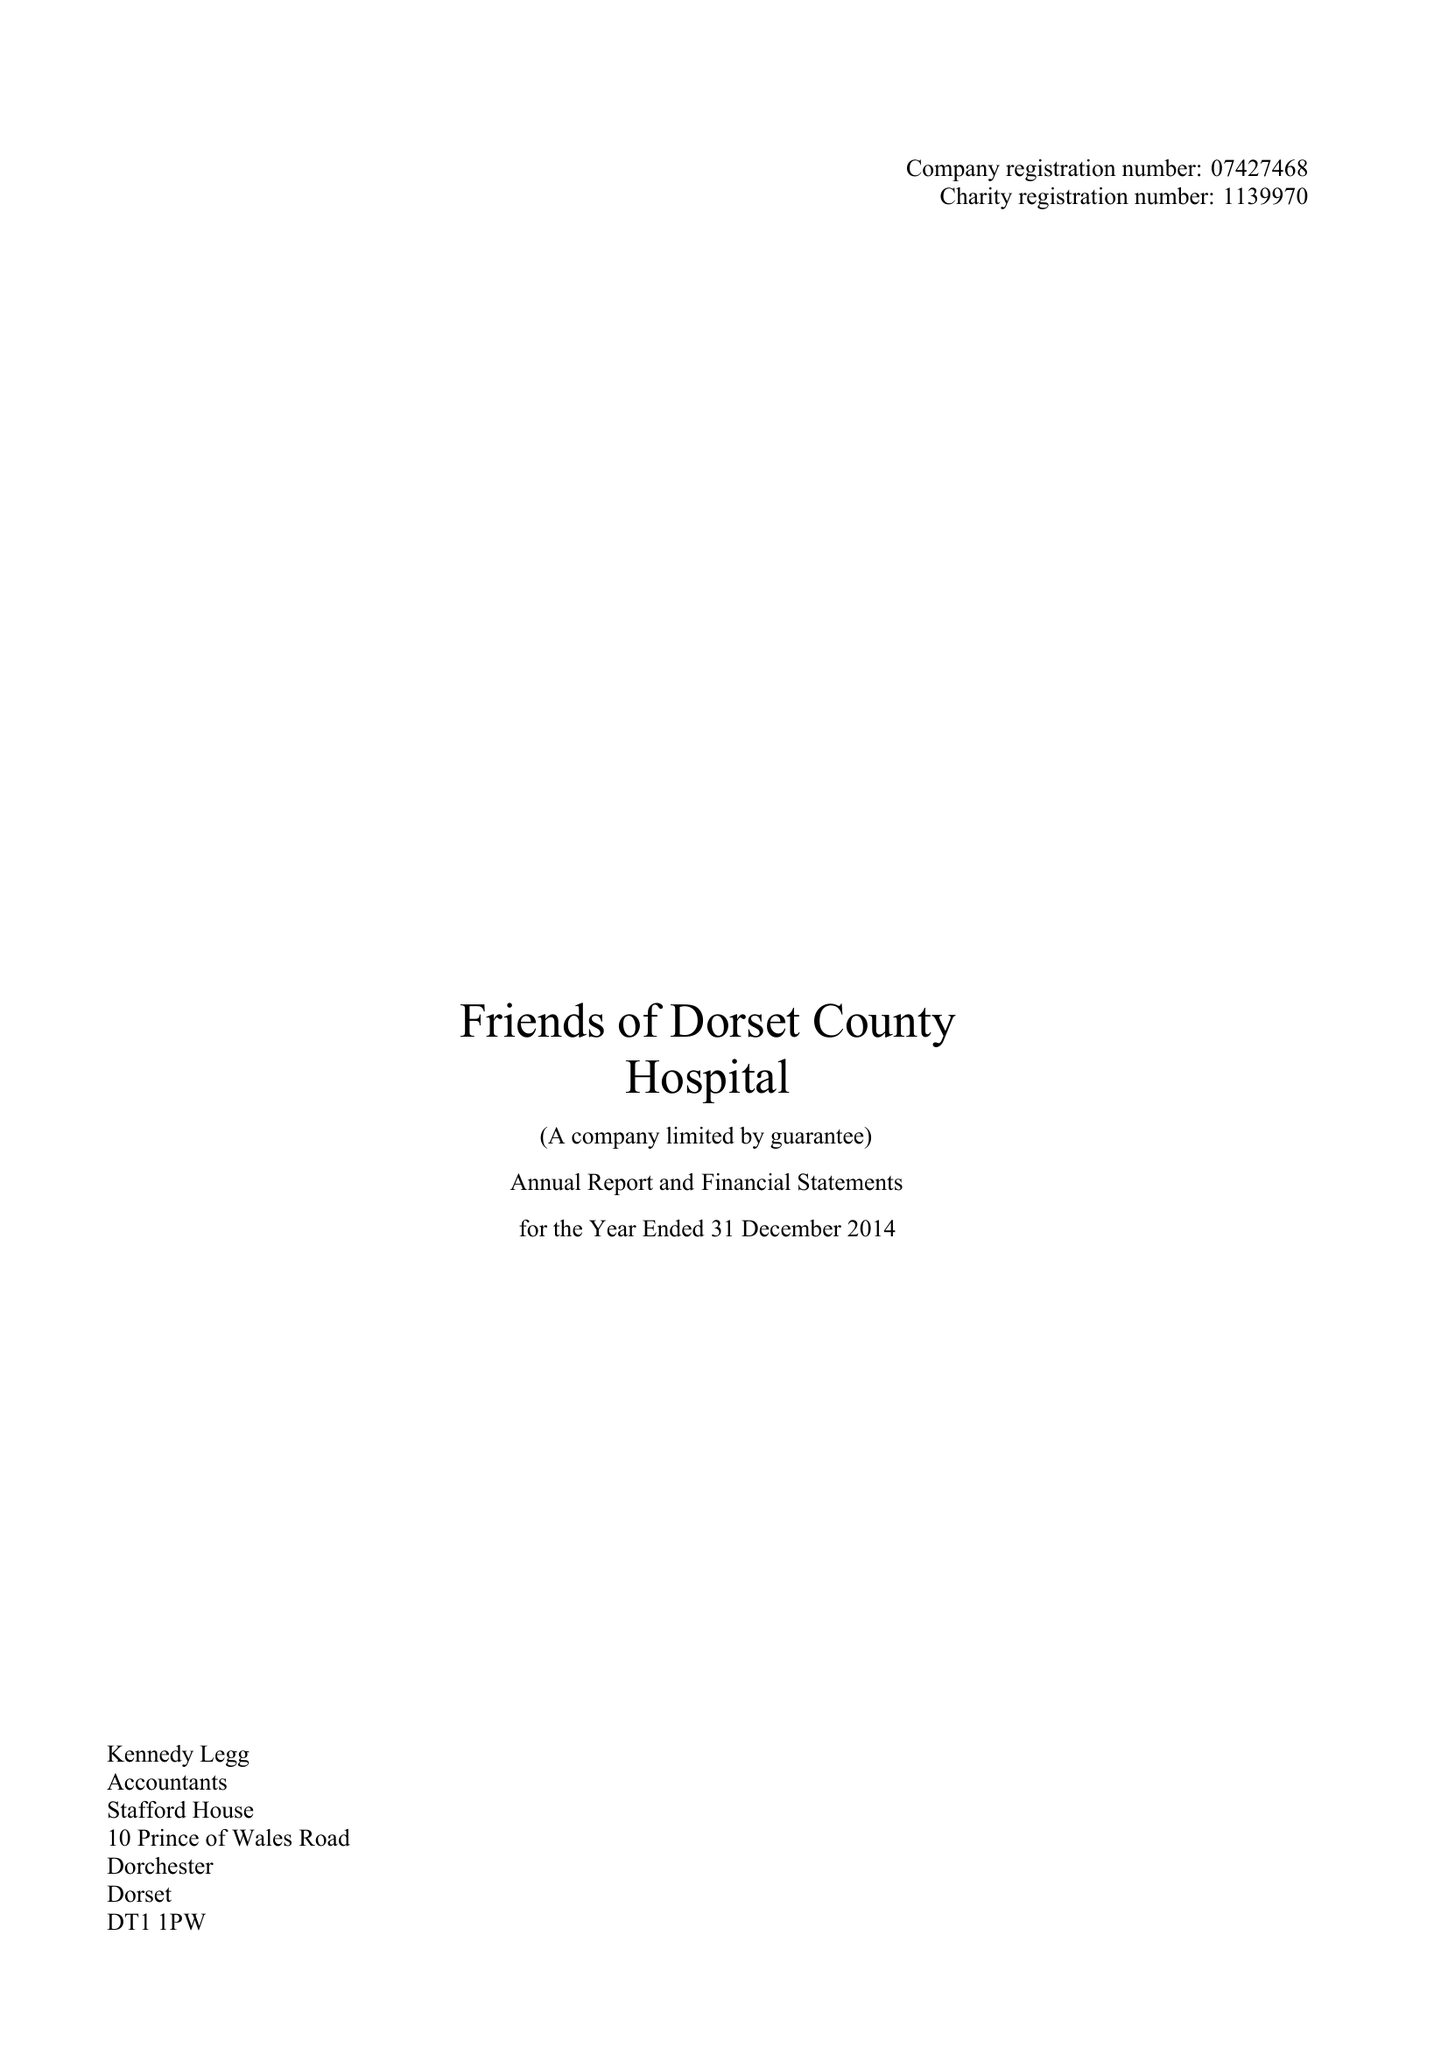What is the value for the report_date?
Answer the question using a single word or phrase. 2014-12-31 